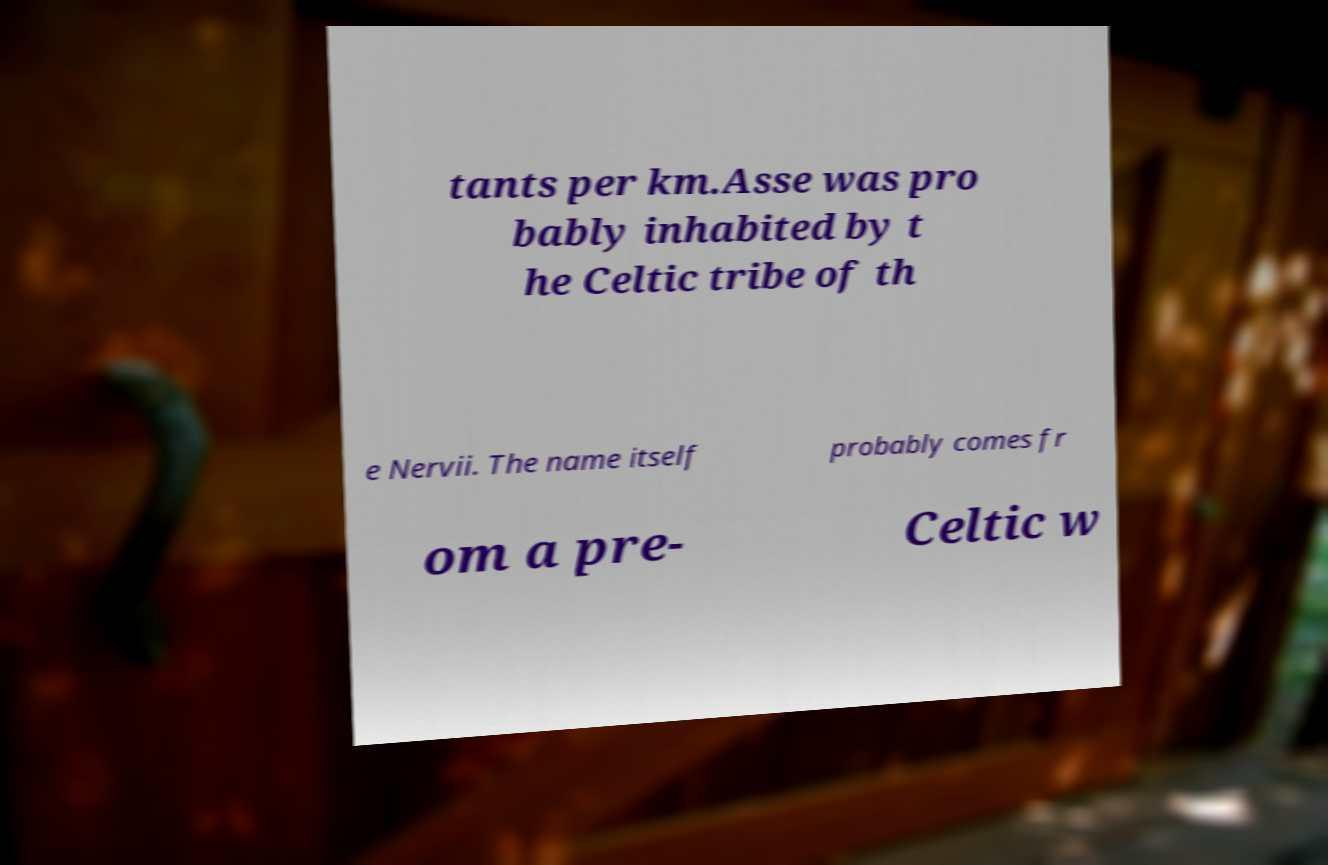What messages or text are displayed in this image? I need them in a readable, typed format. tants per km.Asse was pro bably inhabited by t he Celtic tribe of th e Nervii. The name itself probably comes fr om a pre- Celtic w 